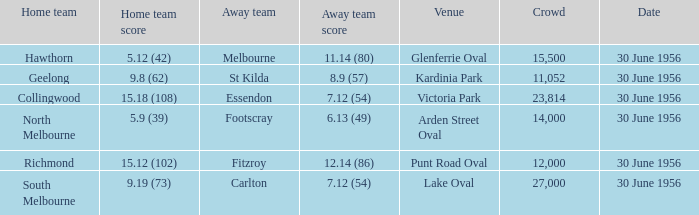What is the home team score when the away team is St Kilda? 9.8 (62). 